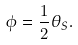<formula> <loc_0><loc_0><loc_500><loc_500>\phi = \frac { 1 } { 2 } \theta _ { S } .</formula> 